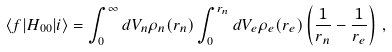Convert formula to latex. <formula><loc_0><loc_0><loc_500><loc_500>\langle f | H _ { 0 0 } | i \rangle = \int _ { 0 } ^ { \infty } d V _ { n } \rho _ { n } ( r _ { n } ) \int _ { 0 } ^ { r _ { n } } d V _ { e } \rho _ { e } ( r _ { e } ) \left ( \frac { 1 } { r _ { n } } - \frac { 1 } { r _ { e } } \right ) \, ,</formula> 